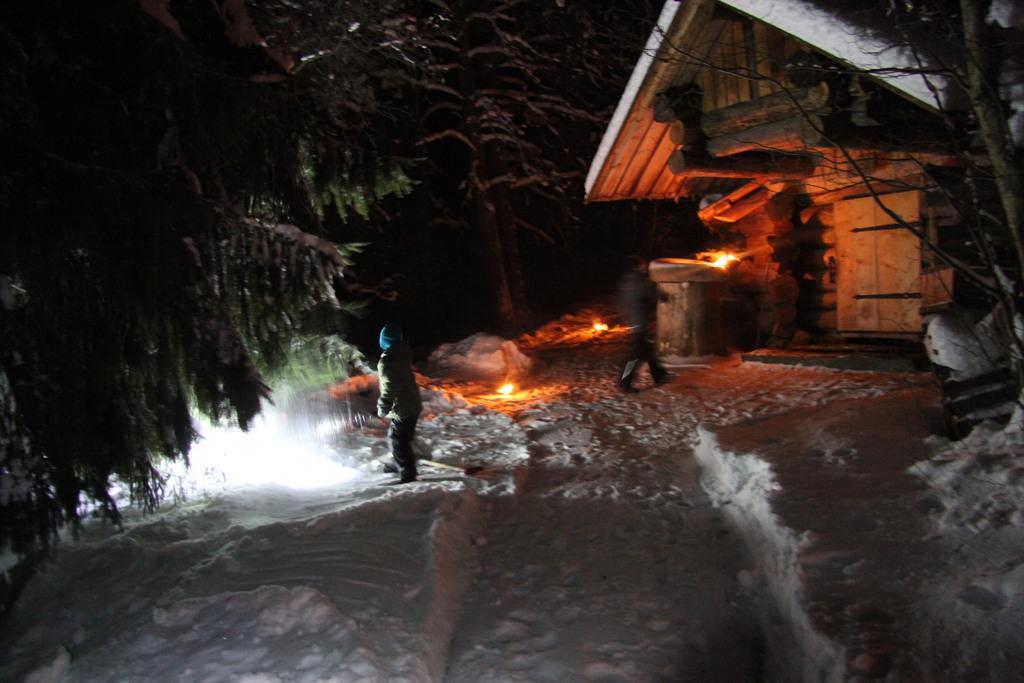Please provide a concise description of this image. In this image we can see ground covered with snow, trees, persons standing and a wooden building. 